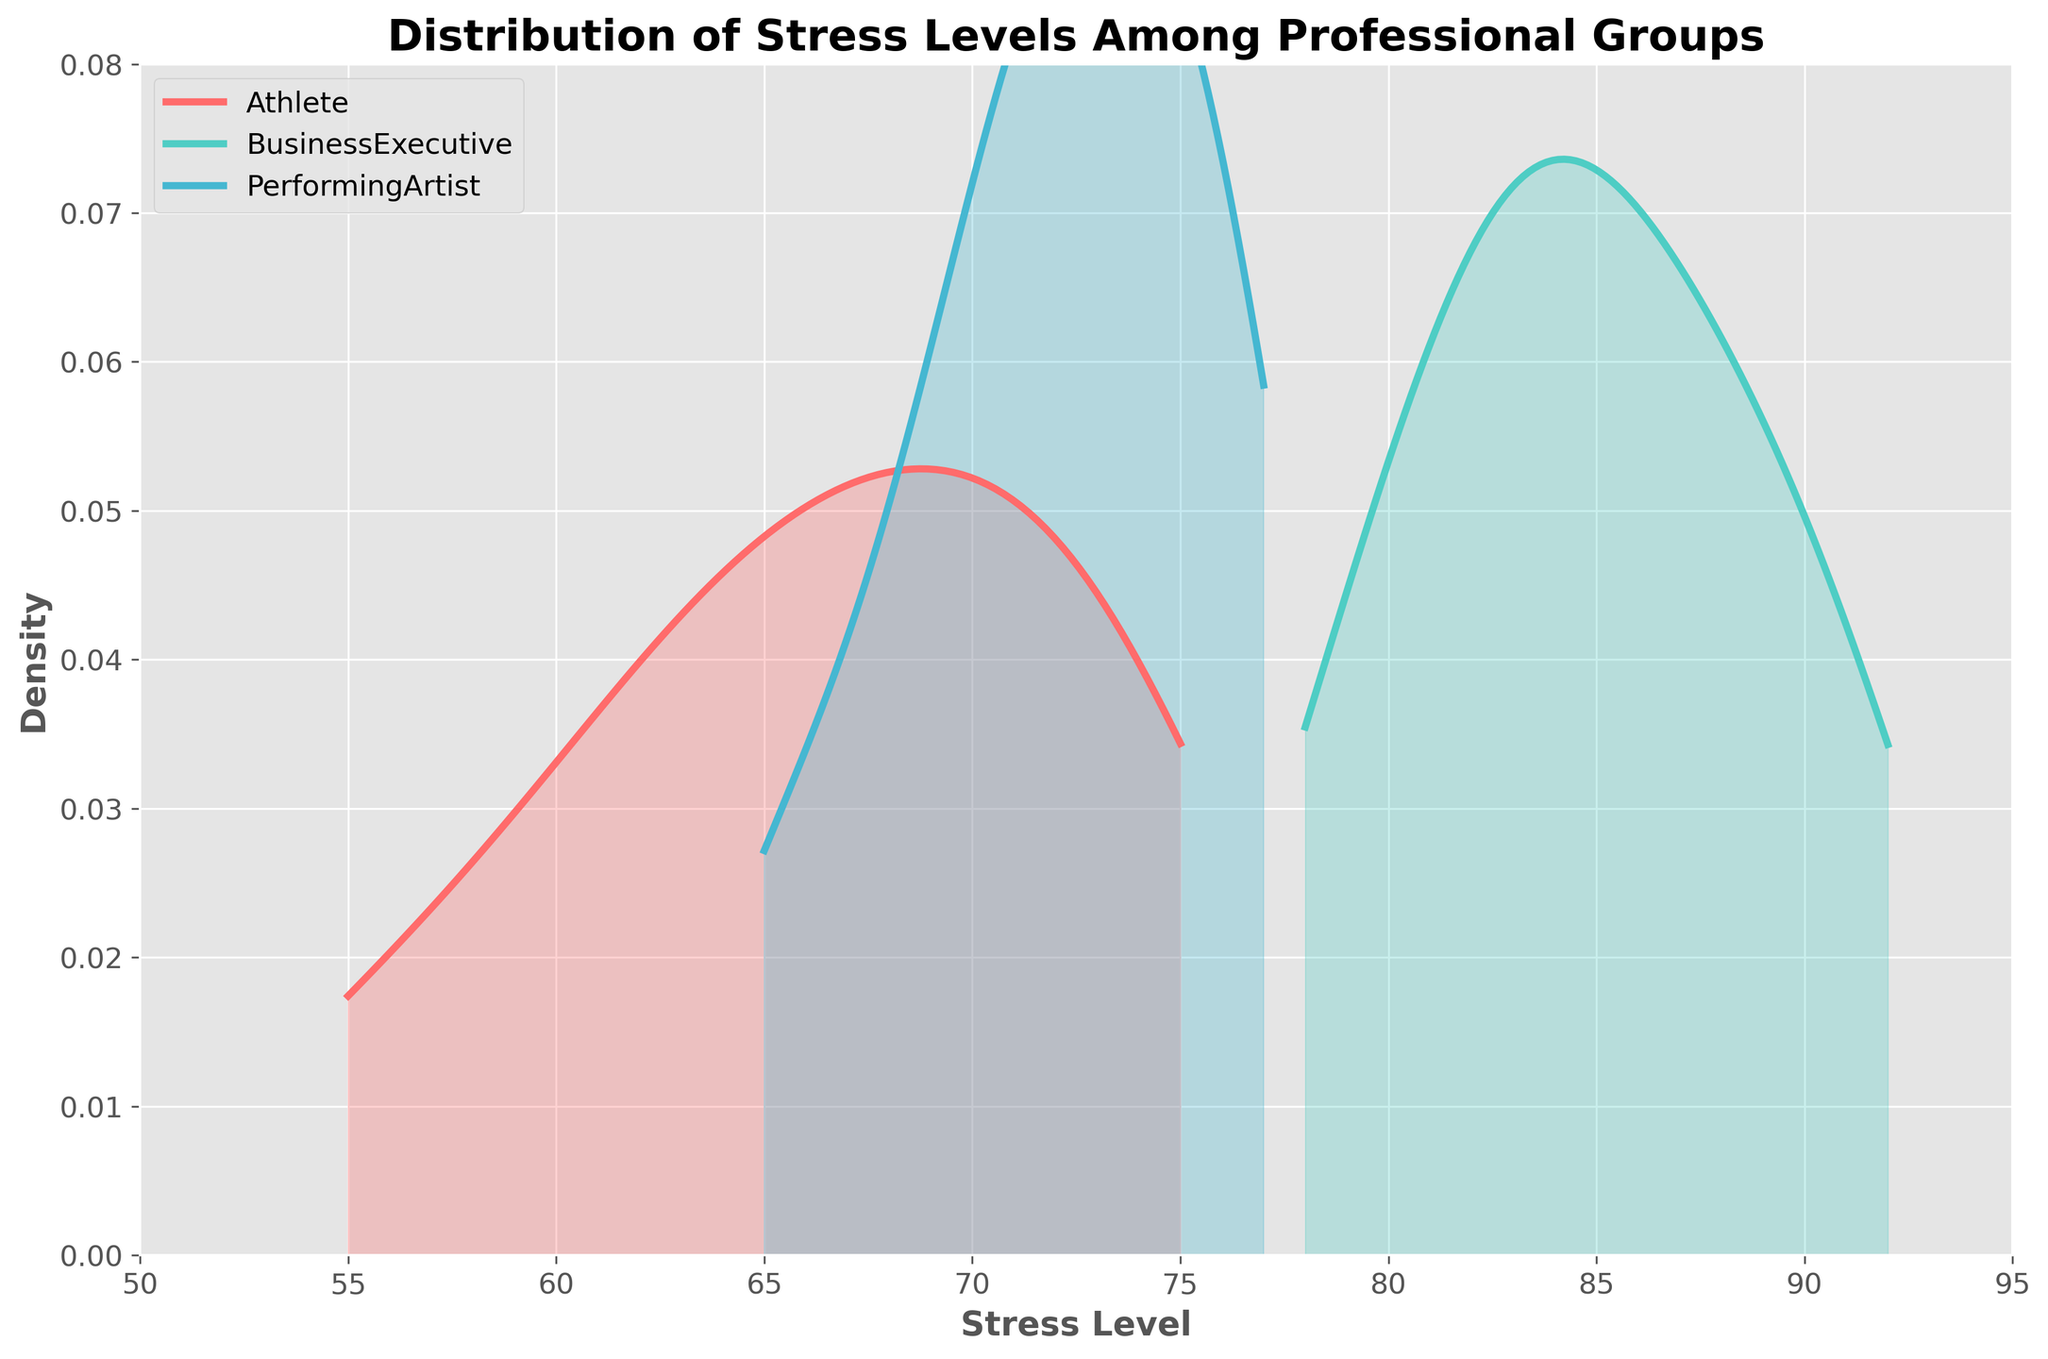How many different professional groups are represented in the plot? The title mentions that the plot shows stress levels among different professional groups, and the legend indicates that there are three groups: Athletes, Business Executives, and Performing Artists.
Answer: Three What is the range of the stress levels displayed in the plot? The x-axis is labeled “Stress Level,” and the range can be seen from the x-axis limits. The range is from 50 to 95.
Answer: 50 to 95 Which professional group has the peak density value closest to 70 on the x-axis? By examining the density peaks around the 70 mark on the x-axis, the group with the peak density closest to this value appears to be Performing Artists, who have a pronounced peak around 70.
Answer: Performing Artists Which group shows the highest overall stress level based on the density plot? By looking at the x-axis and the peaks of the density curves, Business Executives show the highest overall stress levels as their peak is closer to the higher end of the scale (85-90).
Answer: Business Executives Between which two groups is the largest difference in peak stress levels observed? By comparing the peak positions of the density curves, the largest difference is observed between Business Executives and Athletes. Business Executives have peaks around 85-90, while Athletes peak around 65-70.
Answer: Business Executives and Athletes What is the main color used to represent the stress levels of Business Executives? The legend in the plot shows that Business Executives are represented by a turquoise-like color.
Answer: Turquoise What is the approximate density value for the stress level of 75 for Athletes? By finding the stress level of 75 on the x-axis and observing the height of the Athletes' density curve at that point, we estimate the density value to be around 0.04.
Answer: 0.04 Which professional group displays a wider distribution of stress levels? By comparing the spread of the density plots, Business Executives have a wider distribution, as their density spreads more across a broader range on the x-axis compared to the other groups.
Answer: Business Executives Approximately at what stress level does the density plot for Performing Artists peak? By observing the maximum height point of the Performing Artists' density curve, it peaks around the stress level of 70.
Answer: 70 At which stress level do Business Executives start to show notable density? By finding where the density curve for Business Executives starts to rise significantly from the x-axis, it shows notable density starting around 75.
Answer: 75 